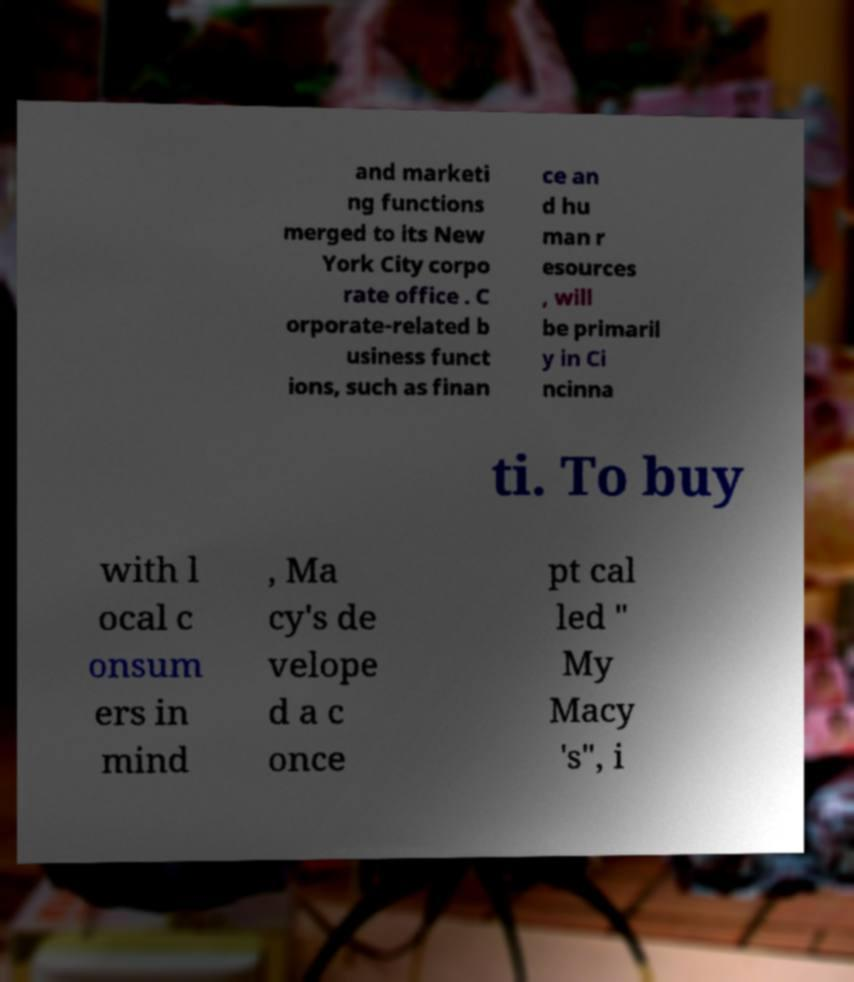Can you accurately transcribe the text from the provided image for me? and marketi ng functions merged to its New York City corpo rate office . C orporate-related b usiness funct ions, such as finan ce an d hu man r esources , will be primaril y in Ci ncinna ti. To buy with l ocal c onsum ers in mind , Ma cy's de velope d a c once pt cal led " My Macy 's", i 